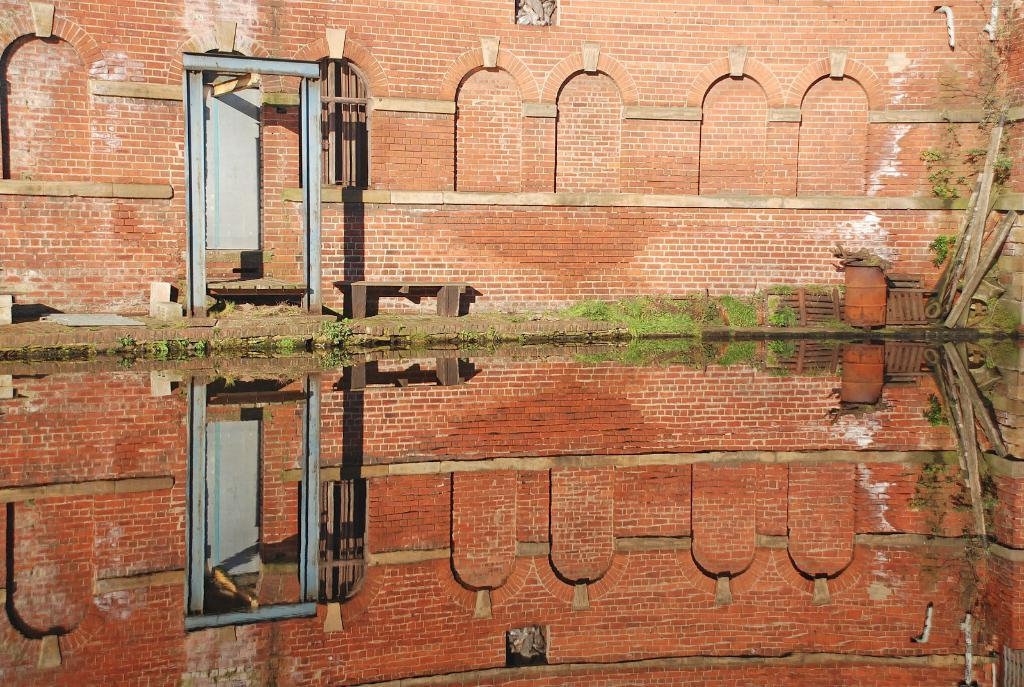What is the primary element visible in the image? There is water in the image. What type of architectural feature can be seen in the image? There is a wall with a door in the image. Is there any source of natural light in the image? Yes, there is a window in the image. What type of vegetation is present in the image? There are plants in the image. Can you describe any other objects visible in the image? There are other unspecified objects in the image. What type of cloth is being used to write the history in the image? There is no cloth or writing of history present in the image. 